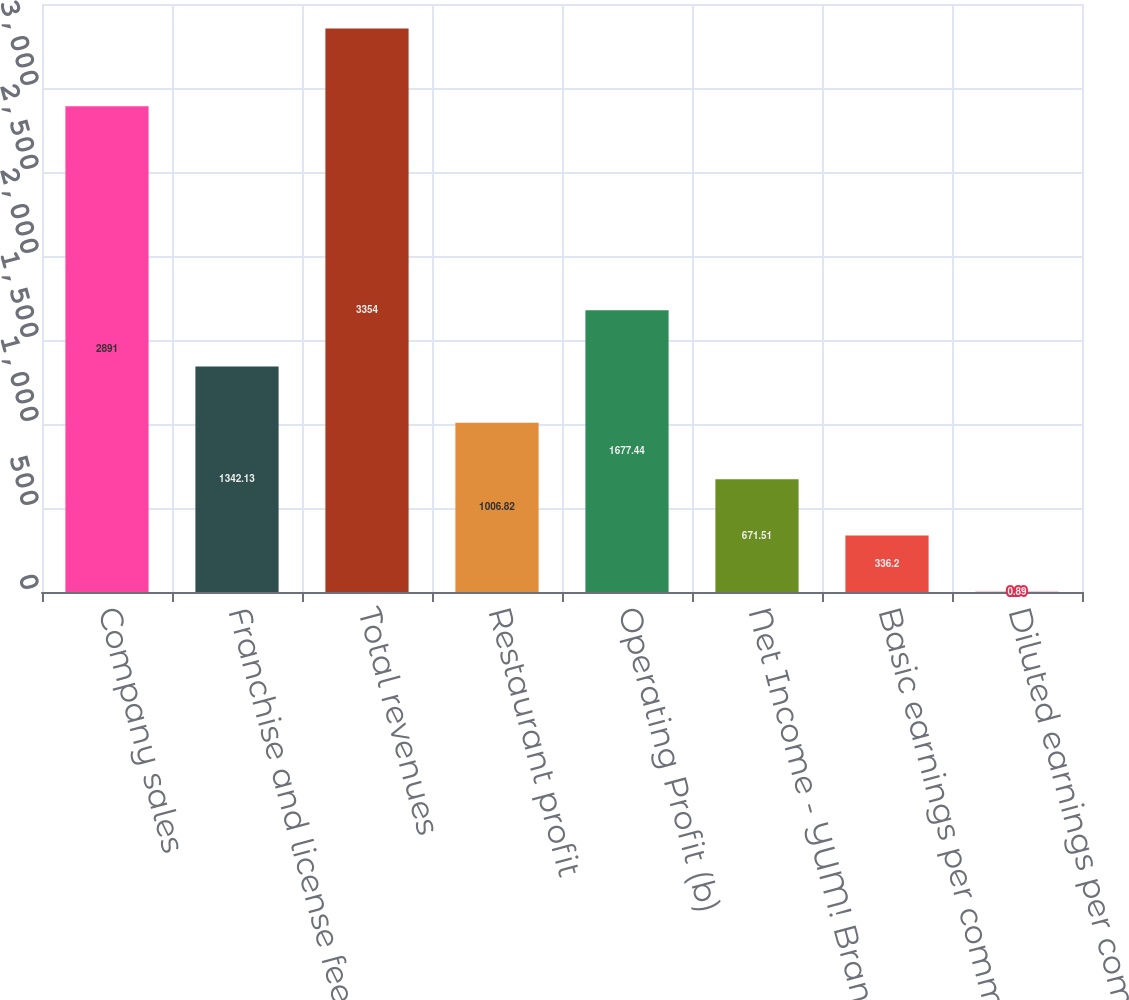Convert chart to OTSL. <chart><loc_0><loc_0><loc_500><loc_500><bar_chart><fcel>Company sales<fcel>Franchise and license fees and<fcel>Total revenues<fcel>Restaurant profit<fcel>Operating Profit (b)<fcel>Net Income - YUM! Brands Inc<fcel>Basic earnings per common<fcel>Diluted earnings per common<nl><fcel>2891<fcel>1342.13<fcel>3354<fcel>1006.82<fcel>1677.44<fcel>671.51<fcel>336.2<fcel>0.89<nl></chart> 